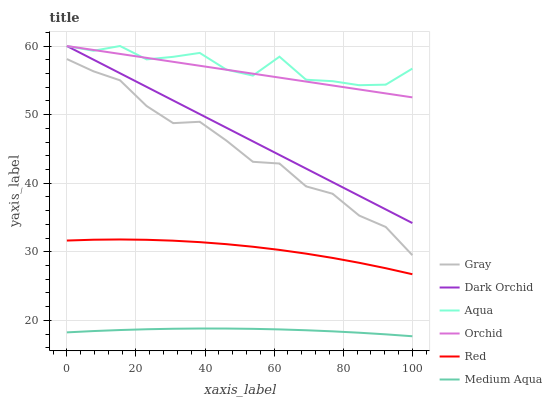Does Medium Aqua have the minimum area under the curve?
Answer yes or no. Yes. Does Aqua have the maximum area under the curve?
Answer yes or no. Yes. Does Dark Orchid have the minimum area under the curve?
Answer yes or no. No. Does Dark Orchid have the maximum area under the curve?
Answer yes or no. No. Is Dark Orchid the smoothest?
Answer yes or no. Yes. Is Aqua the roughest?
Answer yes or no. Yes. Is Aqua the smoothest?
Answer yes or no. No. Is Dark Orchid the roughest?
Answer yes or no. No. Does Dark Orchid have the lowest value?
Answer yes or no. No. Does Medium Aqua have the highest value?
Answer yes or no. No. Is Gray less than Orchid?
Answer yes or no. Yes. Is Dark Orchid greater than Red?
Answer yes or no. Yes. Does Gray intersect Orchid?
Answer yes or no. No. 